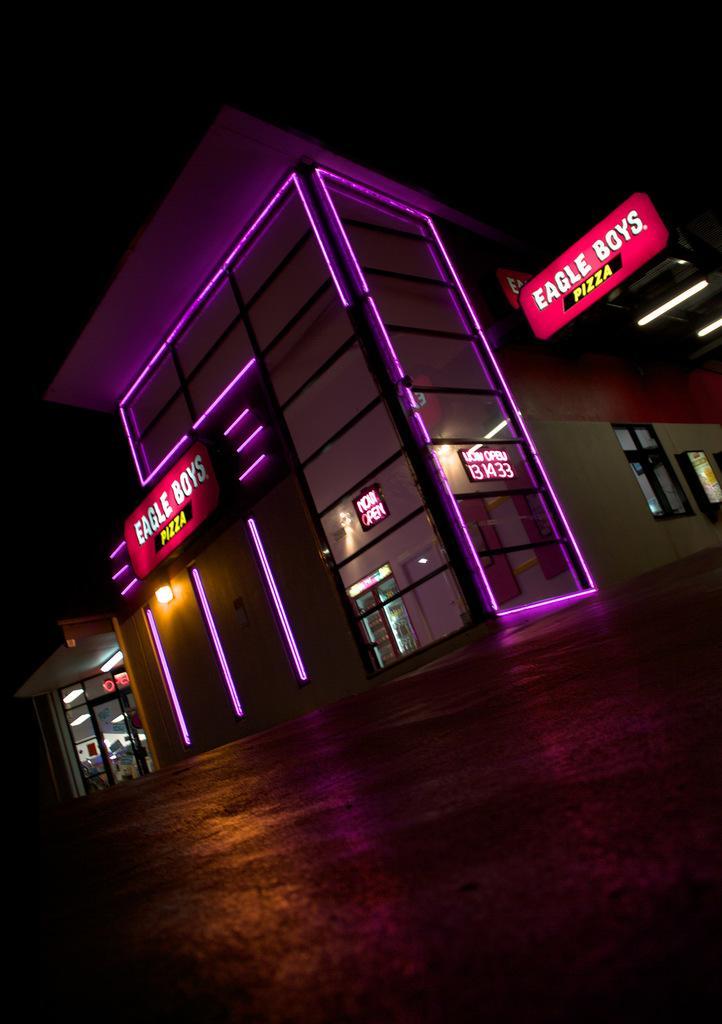How would you summarize this image in a sentence or two? In this image, we can see there is a road. In the background, there are buildings which are having lights and hoardings attached to the walls. And the background is dark in color. 